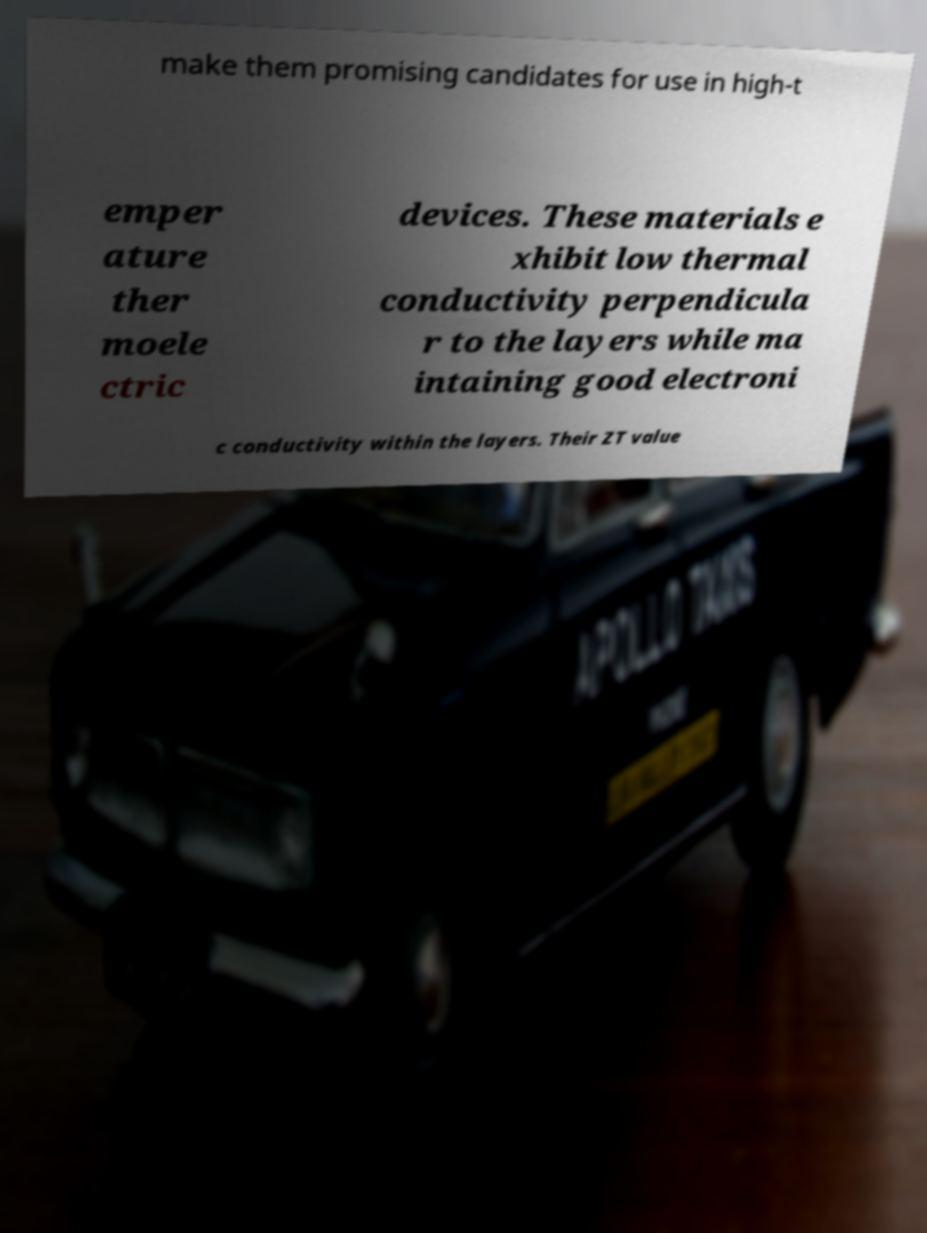Could you extract and type out the text from this image? make them promising candidates for use in high-t emper ature ther moele ctric devices. These materials e xhibit low thermal conductivity perpendicula r to the layers while ma intaining good electroni c conductivity within the layers. Their ZT value 